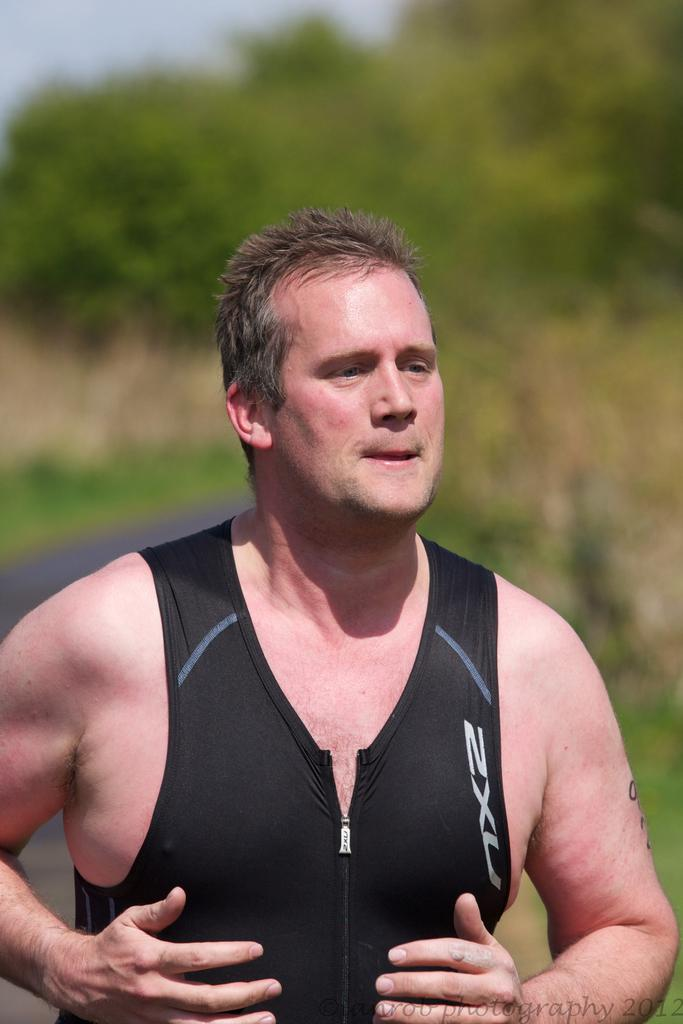<image>
Write a terse but informative summary of the picture. A man wears a black vest with the letters ZXU on it. 